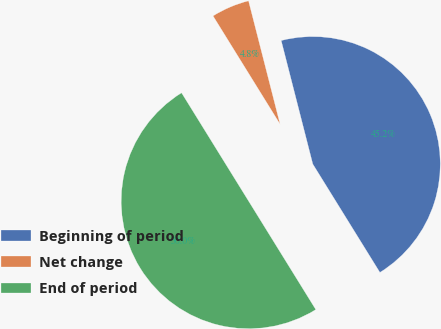Convert chart to OTSL. <chart><loc_0><loc_0><loc_500><loc_500><pie_chart><fcel>Beginning of period<fcel>Net change<fcel>End of period<nl><fcel>45.16%<fcel>4.84%<fcel>50.0%<nl></chart> 